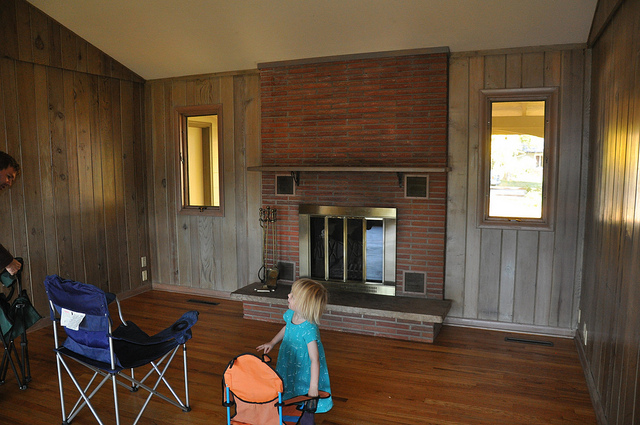<image>What animals are in the picture? There are no animals in the picture. However, humans can be considered as mammals. What animals are in the picture? There are no animals in the picture. It only contains humans. 